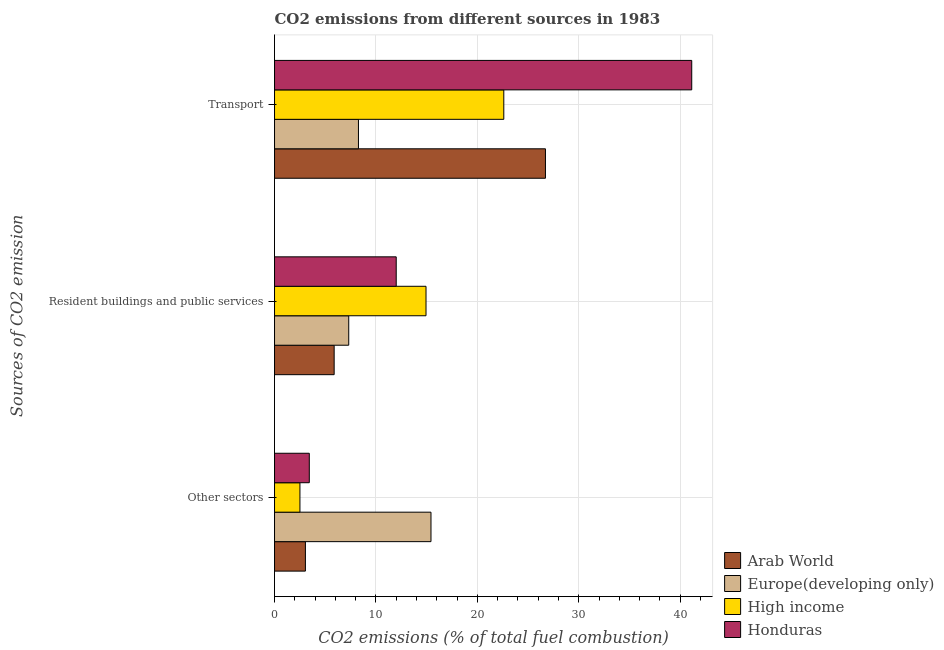How many different coloured bars are there?
Offer a terse response. 4. How many groups of bars are there?
Your answer should be compact. 3. Are the number of bars on each tick of the Y-axis equal?
Provide a short and direct response. Yes. How many bars are there on the 3rd tick from the top?
Your answer should be very brief. 4. What is the label of the 1st group of bars from the top?
Your answer should be compact. Transport. What is the percentage of co2 emissions from other sectors in Arab World?
Ensure brevity in your answer.  3.05. Across all countries, what is the maximum percentage of co2 emissions from other sectors?
Provide a succinct answer. 15.43. Across all countries, what is the minimum percentage of co2 emissions from other sectors?
Keep it short and to the point. 2.51. In which country was the percentage of co2 emissions from transport maximum?
Give a very brief answer. Honduras. In which country was the percentage of co2 emissions from resident buildings and public services minimum?
Your response must be concise. Arab World. What is the total percentage of co2 emissions from resident buildings and public services in the graph?
Provide a short and direct response. 40.14. What is the difference between the percentage of co2 emissions from resident buildings and public services in Honduras and that in Europe(developing only)?
Offer a terse response. 4.68. What is the difference between the percentage of co2 emissions from resident buildings and public services in Honduras and the percentage of co2 emissions from other sectors in Arab World?
Provide a succinct answer. 8.95. What is the average percentage of co2 emissions from other sectors per country?
Provide a short and direct response. 6.1. What is the difference between the percentage of co2 emissions from transport and percentage of co2 emissions from other sectors in Honduras?
Give a very brief answer. 37.71. In how many countries, is the percentage of co2 emissions from transport greater than 10 %?
Make the answer very short. 3. What is the ratio of the percentage of co2 emissions from resident buildings and public services in High income to that in Europe(developing only)?
Your answer should be very brief. 2.04. Is the percentage of co2 emissions from transport in High income less than that in Honduras?
Offer a terse response. Yes. Is the difference between the percentage of co2 emissions from resident buildings and public services in High income and Honduras greater than the difference between the percentage of co2 emissions from other sectors in High income and Honduras?
Give a very brief answer. Yes. What is the difference between the highest and the second highest percentage of co2 emissions from transport?
Give a very brief answer. 14.43. What is the difference between the highest and the lowest percentage of co2 emissions from transport?
Provide a short and direct response. 32.87. What does the 1st bar from the top in Resident buildings and public services represents?
Your answer should be compact. Honduras. What does the 1st bar from the bottom in Resident buildings and public services represents?
Give a very brief answer. Arab World. Is it the case that in every country, the sum of the percentage of co2 emissions from other sectors and percentage of co2 emissions from resident buildings and public services is greater than the percentage of co2 emissions from transport?
Provide a succinct answer. No. Are all the bars in the graph horizontal?
Offer a very short reply. Yes. What is the difference between two consecutive major ticks on the X-axis?
Provide a short and direct response. 10. Are the values on the major ticks of X-axis written in scientific E-notation?
Provide a short and direct response. No. Does the graph contain grids?
Offer a very short reply. Yes. Where does the legend appear in the graph?
Keep it short and to the point. Bottom right. What is the title of the graph?
Your answer should be compact. CO2 emissions from different sources in 1983. Does "Indonesia" appear as one of the legend labels in the graph?
Your answer should be compact. No. What is the label or title of the X-axis?
Keep it short and to the point. CO2 emissions (% of total fuel combustion). What is the label or title of the Y-axis?
Offer a very short reply. Sources of CO2 emission. What is the CO2 emissions (% of total fuel combustion) in Arab World in Other sectors?
Provide a succinct answer. 3.05. What is the CO2 emissions (% of total fuel combustion) in Europe(developing only) in Other sectors?
Your answer should be very brief. 15.43. What is the CO2 emissions (% of total fuel combustion) in High income in Other sectors?
Keep it short and to the point. 2.51. What is the CO2 emissions (% of total fuel combustion) in Honduras in Other sectors?
Your answer should be very brief. 3.43. What is the CO2 emissions (% of total fuel combustion) in Arab World in Resident buildings and public services?
Offer a very short reply. 5.88. What is the CO2 emissions (% of total fuel combustion) of Europe(developing only) in Resident buildings and public services?
Provide a short and direct response. 7.32. What is the CO2 emissions (% of total fuel combustion) in High income in Resident buildings and public services?
Your answer should be very brief. 14.94. What is the CO2 emissions (% of total fuel combustion) in Arab World in Transport?
Provide a short and direct response. 26.72. What is the CO2 emissions (% of total fuel combustion) in Europe(developing only) in Transport?
Your answer should be very brief. 8.28. What is the CO2 emissions (% of total fuel combustion) in High income in Transport?
Offer a very short reply. 22.61. What is the CO2 emissions (% of total fuel combustion) in Honduras in Transport?
Ensure brevity in your answer.  41.14. Across all Sources of CO2 emission, what is the maximum CO2 emissions (% of total fuel combustion) in Arab World?
Provide a short and direct response. 26.72. Across all Sources of CO2 emission, what is the maximum CO2 emissions (% of total fuel combustion) in Europe(developing only)?
Your answer should be compact. 15.43. Across all Sources of CO2 emission, what is the maximum CO2 emissions (% of total fuel combustion) in High income?
Provide a succinct answer. 22.61. Across all Sources of CO2 emission, what is the maximum CO2 emissions (% of total fuel combustion) in Honduras?
Your answer should be very brief. 41.14. Across all Sources of CO2 emission, what is the minimum CO2 emissions (% of total fuel combustion) in Arab World?
Offer a very short reply. 3.05. Across all Sources of CO2 emission, what is the minimum CO2 emissions (% of total fuel combustion) in Europe(developing only)?
Give a very brief answer. 7.32. Across all Sources of CO2 emission, what is the minimum CO2 emissions (% of total fuel combustion) in High income?
Make the answer very short. 2.51. Across all Sources of CO2 emission, what is the minimum CO2 emissions (% of total fuel combustion) of Honduras?
Ensure brevity in your answer.  3.43. What is the total CO2 emissions (% of total fuel combustion) of Arab World in the graph?
Your answer should be compact. 35.64. What is the total CO2 emissions (% of total fuel combustion) of Europe(developing only) in the graph?
Offer a terse response. 31.02. What is the total CO2 emissions (% of total fuel combustion) of High income in the graph?
Make the answer very short. 40.05. What is the total CO2 emissions (% of total fuel combustion) of Honduras in the graph?
Provide a succinct answer. 56.57. What is the difference between the CO2 emissions (% of total fuel combustion) in Arab World in Other sectors and that in Resident buildings and public services?
Provide a succinct answer. -2.83. What is the difference between the CO2 emissions (% of total fuel combustion) of Europe(developing only) in Other sectors and that in Resident buildings and public services?
Provide a succinct answer. 8.11. What is the difference between the CO2 emissions (% of total fuel combustion) in High income in Other sectors and that in Resident buildings and public services?
Keep it short and to the point. -12.43. What is the difference between the CO2 emissions (% of total fuel combustion) of Honduras in Other sectors and that in Resident buildings and public services?
Offer a terse response. -8.57. What is the difference between the CO2 emissions (% of total fuel combustion) in Arab World in Other sectors and that in Transport?
Make the answer very short. -23.67. What is the difference between the CO2 emissions (% of total fuel combustion) in Europe(developing only) in Other sectors and that in Transport?
Your response must be concise. 7.15. What is the difference between the CO2 emissions (% of total fuel combustion) of High income in Other sectors and that in Transport?
Keep it short and to the point. -20.1. What is the difference between the CO2 emissions (% of total fuel combustion) in Honduras in Other sectors and that in Transport?
Your answer should be compact. -37.71. What is the difference between the CO2 emissions (% of total fuel combustion) of Arab World in Resident buildings and public services and that in Transport?
Offer a very short reply. -20.84. What is the difference between the CO2 emissions (% of total fuel combustion) in Europe(developing only) in Resident buildings and public services and that in Transport?
Give a very brief answer. -0.96. What is the difference between the CO2 emissions (% of total fuel combustion) in High income in Resident buildings and public services and that in Transport?
Keep it short and to the point. -7.67. What is the difference between the CO2 emissions (% of total fuel combustion) of Honduras in Resident buildings and public services and that in Transport?
Your answer should be very brief. -29.14. What is the difference between the CO2 emissions (% of total fuel combustion) in Arab World in Other sectors and the CO2 emissions (% of total fuel combustion) in Europe(developing only) in Resident buildings and public services?
Your answer should be compact. -4.27. What is the difference between the CO2 emissions (% of total fuel combustion) of Arab World in Other sectors and the CO2 emissions (% of total fuel combustion) of High income in Resident buildings and public services?
Provide a succinct answer. -11.89. What is the difference between the CO2 emissions (% of total fuel combustion) of Arab World in Other sectors and the CO2 emissions (% of total fuel combustion) of Honduras in Resident buildings and public services?
Your response must be concise. -8.95. What is the difference between the CO2 emissions (% of total fuel combustion) of Europe(developing only) in Other sectors and the CO2 emissions (% of total fuel combustion) of High income in Resident buildings and public services?
Provide a short and direct response. 0.49. What is the difference between the CO2 emissions (% of total fuel combustion) in Europe(developing only) in Other sectors and the CO2 emissions (% of total fuel combustion) in Honduras in Resident buildings and public services?
Provide a succinct answer. 3.43. What is the difference between the CO2 emissions (% of total fuel combustion) in High income in Other sectors and the CO2 emissions (% of total fuel combustion) in Honduras in Resident buildings and public services?
Offer a very short reply. -9.49. What is the difference between the CO2 emissions (% of total fuel combustion) in Arab World in Other sectors and the CO2 emissions (% of total fuel combustion) in Europe(developing only) in Transport?
Give a very brief answer. -5.23. What is the difference between the CO2 emissions (% of total fuel combustion) of Arab World in Other sectors and the CO2 emissions (% of total fuel combustion) of High income in Transport?
Offer a terse response. -19.56. What is the difference between the CO2 emissions (% of total fuel combustion) of Arab World in Other sectors and the CO2 emissions (% of total fuel combustion) of Honduras in Transport?
Offer a terse response. -38.1. What is the difference between the CO2 emissions (% of total fuel combustion) in Europe(developing only) in Other sectors and the CO2 emissions (% of total fuel combustion) in High income in Transport?
Provide a succinct answer. -7.18. What is the difference between the CO2 emissions (% of total fuel combustion) in Europe(developing only) in Other sectors and the CO2 emissions (% of total fuel combustion) in Honduras in Transport?
Offer a terse response. -25.71. What is the difference between the CO2 emissions (% of total fuel combustion) in High income in Other sectors and the CO2 emissions (% of total fuel combustion) in Honduras in Transport?
Keep it short and to the point. -38.64. What is the difference between the CO2 emissions (% of total fuel combustion) in Arab World in Resident buildings and public services and the CO2 emissions (% of total fuel combustion) in Europe(developing only) in Transport?
Offer a very short reply. -2.4. What is the difference between the CO2 emissions (% of total fuel combustion) in Arab World in Resident buildings and public services and the CO2 emissions (% of total fuel combustion) in High income in Transport?
Your response must be concise. -16.73. What is the difference between the CO2 emissions (% of total fuel combustion) of Arab World in Resident buildings and public services and the CO2 emissions (% of total fuel combustion) of Honduras in Transport?
Your response must be concise. -35.26. What is the difference between the CO2 emissions (% of total fuel combustion) in Europe(developing only) in Resident buildings and public services and the CO2 emissions (% of total fuel combustion) in High income in Transport?
Your response must be concise. -15.29. What is the difference between the CO2 emissions (% of total fuel combustion) in Europe(developing only) in Resident buildings and public services and the CO2 emissions (% of total fuel combustion) in Honduras in Transport?
Your response must be concise. -33.83. What is the difference between the CO2 emissions (% of total fuel combustion) in High income in Resident buildings and public services and the CO2 emissions (% of total fuel combustion) in Honduras in Transport?
Provide a succinct answer. -26.2. What is the average CO2 emissions (% of total fuel combustion) in Arab World per Sources of CO2 emission?
Give a very brief answer. 11.88. What is the average CO2 emissions (% of total fuel combustion) of Europe(developing only) per Sources of CO2 emission?
Provide a short and direct response. 10.34. What is the average CO2 emissions (% of total fuel combustion) of High income per Sources of CO2 emission?
Give a very brief answer. 13.35. What is the average CO2 emissions (% of total fuel combustion) in Honduras per Sources of CO2 emission?
Offer a very short reply. 18.86. What is the difference between the CO2 emissions (% of total fuel combustion) in Arab World and CO2 emissions (% of total fuel combustion) in Europe(developing only) in Other sectors?
Your answer should be very brief. -12.38. What is the difference between the CO2 emissions (% of total fuel combustion) in Arab World and CO2 emissions (% of total fuel combustion) in High income in Other sectors?
Your answer should be compact. 0.54. What is the difference between the CO2 emissions (% of total fuel combustion) in Arab World and CO2 emissions (% of total fuel combustion) in Honduras in Other sectors?
Provide a short and direct response. -0.38. What is the difference between the CO2 emissions (% of total fuel combustion) of Europe(developing only) and CO2 emissions (% of total fuel combustion) of High income in Other sectors?
Give a very brief answer. 12.92. What is the difference between the CO2 emissions (% of total fuel combustion) in Europe(developing only) and CO2 emissions (% of total fuel combustion) in Honduras in Other sectors?
Offer a very short reply. 12. What is the difference between the CO2 emissions (% of total fuel combustion) in High income and CO2 emissions (% of total fuel combustion) in Honduras in Other sectors?
Provide a succinct answer. -0.92. What is the difference between the CO2 emissions (% of total fuel combustion) of Arab World and CO2 emissions (% of total fuel combustion) of Europe(developing only) in Resident buildings and public services?
Your response must be concise. -1.44. What is the difference between the CO2 emissions (% of total fuel combustion) in Arab World and CO2 emissions (% of total fuel combustion) in High income in Resident buildings and public services?
Provide a short and direct response. -9.06. What is the difference between the CO2 emissions (% of total fuel combustion) in Arab World and CO2 emissions (% of total fuel combustion) in Honduras in Resident buildings and public services?
Your answer should be very brief. -6.12. What is the difference between the CO2 emissions (% of total fuel combustion) of Europe(developing only) and CO2 emissions (% of total fuel combustion) of High income in Resident buildings and public services?
Provide a short and direct response. -7.62. What is the difference between the CO2 emissions (% of total fuel combustion) of Europe(developing only) and CO2 emissions (% of total fuel combustion) of Honduras in Resident buildings and public services?
Your response must be concise. -4.68. What is the difference between the CO2 emissions (% of total fuel combustion) in High income and CO2 emissions (% of total fuel combustion) in Honduras in Resident buildings and public services?
Keep it short and to the point. 2.94. What is the difference between the CO2 emissions (% of total fuel combustion) in Arab World and CO2 emissions (% of total fuel combustion) in Europe(developing only) in Transport?
Keep it short and to the point. 18.44. What is the difference between the CO2 emissions (% of total fuel combustion) of Arab World and CO2 emissions (% of total fuel combustion) of High income in Transport?
Offer a terse response. 4.11. What is the difference between the CO2 emissions (% of total fuel combustion) of Arab World and CO2 emissions (% of total fuel combustion) of Honduras in Transport?
Give a very brief answer. -14.43. What is the difference between the CO2 emissions (% of total fuel combustion) of Europe(developing only) and CO2 emissions (% of total fuel combustion) of High income in Transport?
Your response must be concise. -14.33. What is the difference between the CO2 emissions (% of total fuel combustion) in Europe(developing only) and CO2 emissions (% of total fuel combustion) in Honduras in Transport?
Keep it short and to the point. -32.87. What is the difference between the CO2 emissions (% of total fuel combustion) of High income and CO2 emissions (% of total fuel combustion) of Honduras in Transport?
Your answer should be compact. -18.53. What is the ratio of the CO2 emissions (% of total fuel combustion) in Arab World in Other sectors to that in Resident buildings and public services?
Provide a succinct answer. 0.52. What is the ratio of the CO2 emissions (% of total fuel combustion) in Europe(developing only) in Other sectors to that in Resident buildings and public services?
Ensure brevity in your answer.  2.11. What is the ratio of the CO2 emissions (% of total fuel combustion) of High income in Other sectors to that in Resident buildings and public services?
Provide a succinct answer. 0.17. What is the ratio of the CO2 emissions (% of total fuel combustion) of Honduras in Other sectors to that in Resident buildings and public services?
Offer a terse response. 0.29. What is the ratio of the CO2 emissions (% of total fuel combustion) of Arab World in Other sectors to that in Transport?
Your response must be concise. 0.11. What is the ratio of the CO2 emissions (% of total fuel combustion) in Europe(developing only) in Other sectors to that in Transport?
Provide a succinct answer. 1.86. What is the ratio of the CO2 emissions (% of total fuel combustion) in High income in Other sectors to that in Transport?
Provide a succinct answer. 0.11. What is the ratio of the CO2 emissions (% of total fuel combustion) of Honduras in Other sectors to that in Transport?
Give a very brief answer. 0.08. What is the ratio of the CO2 emissions (% of total fuel combustion) in Arab World in Resident buildings and public services to that in Transport?
Make the answer very short. 0.22. What is the ratio of the CO2 emissions (% of total fuel combustion) in Europe(developing only) in Resident buildings and public services to that in Transport?
Offer a terse response. 0.88. What is the ratio of the CO2 emissions (% of total fuel combustion) of High income in Resident buildings and public services to that in Transport?
Provide a succinct answer. 0.66. What is the ratio of the CO2 emissions (% of total fuel combustion) of Honduras in Resident buildings and public services to that in Transport?
Give a very brief answer. 0.29. What is the difference between the highest and the second highest CO2 emissions (% of total fuel combustion) in Arab World?
Offer a terse response. 20.84. What is the difference between the highest and the second highest CO2 emissions (% of total fuel combustion) of Europe(developing only)?
Your answer should be very brief. 7.15. What is the difference between the highest and the second highest CO2 emissions (% of total fuel combustion) in High income?
Provide a short and direct response. 7.67. What is the difference between the highest and the second highest CO2 emissions (% of total fuel combustion) of Honduras?
Give a very brief answer. 29.14. What is the difference between the highest and the lowest CO2 emissions (% of total fuel combustion) in Arab World?
Your response must be concise. 23.67. What is the difference between the highest and the lowest CO2 emissions (% of total fuel combustion) of Europe(developing only)?
Keep it short and to the point. 8.11. What is the difference between the highest and the lowest CO2 emissions (% of total fuel combustion) of High income?
Offer a very short reply. 20.1. What is the difference between the highest and the lowest CO2 emissions (% of total fuel combustion) of Honduras?
Your answer should be very brief. 37.71. 